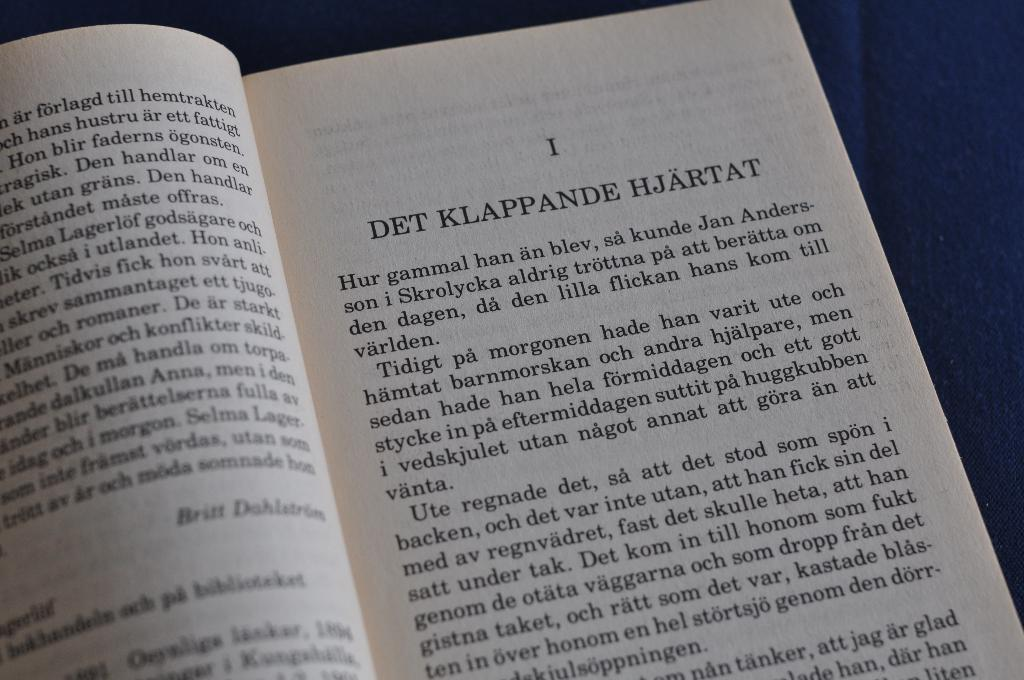<image>
Share a concise interpretation of the image provided. A new chapter in an open book titled "DET KLAPPANDE HJARTAT" 